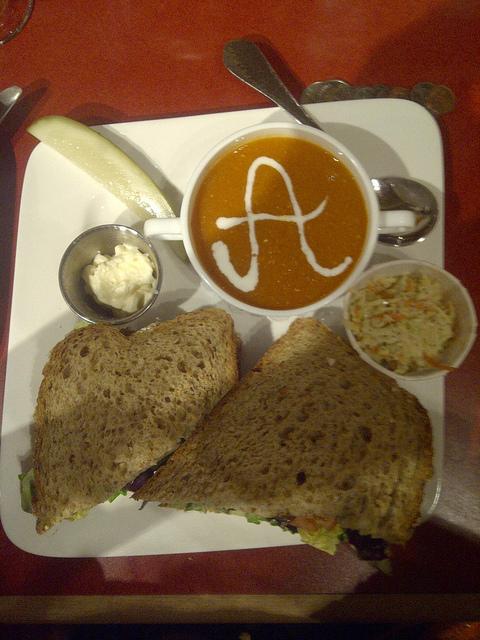What letter is written in the soup?
Quick response, please. A. Is there a pickle?
Quick response, please. Yes. Where is the spoon?
Write a very short answer. On plate. 